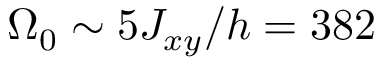<formula> <loc_0><loc_0><loc_500><loc_500>\Omega _ { 0 } \sim 5 J _ { x y } / h = 3 8 2</formula> 